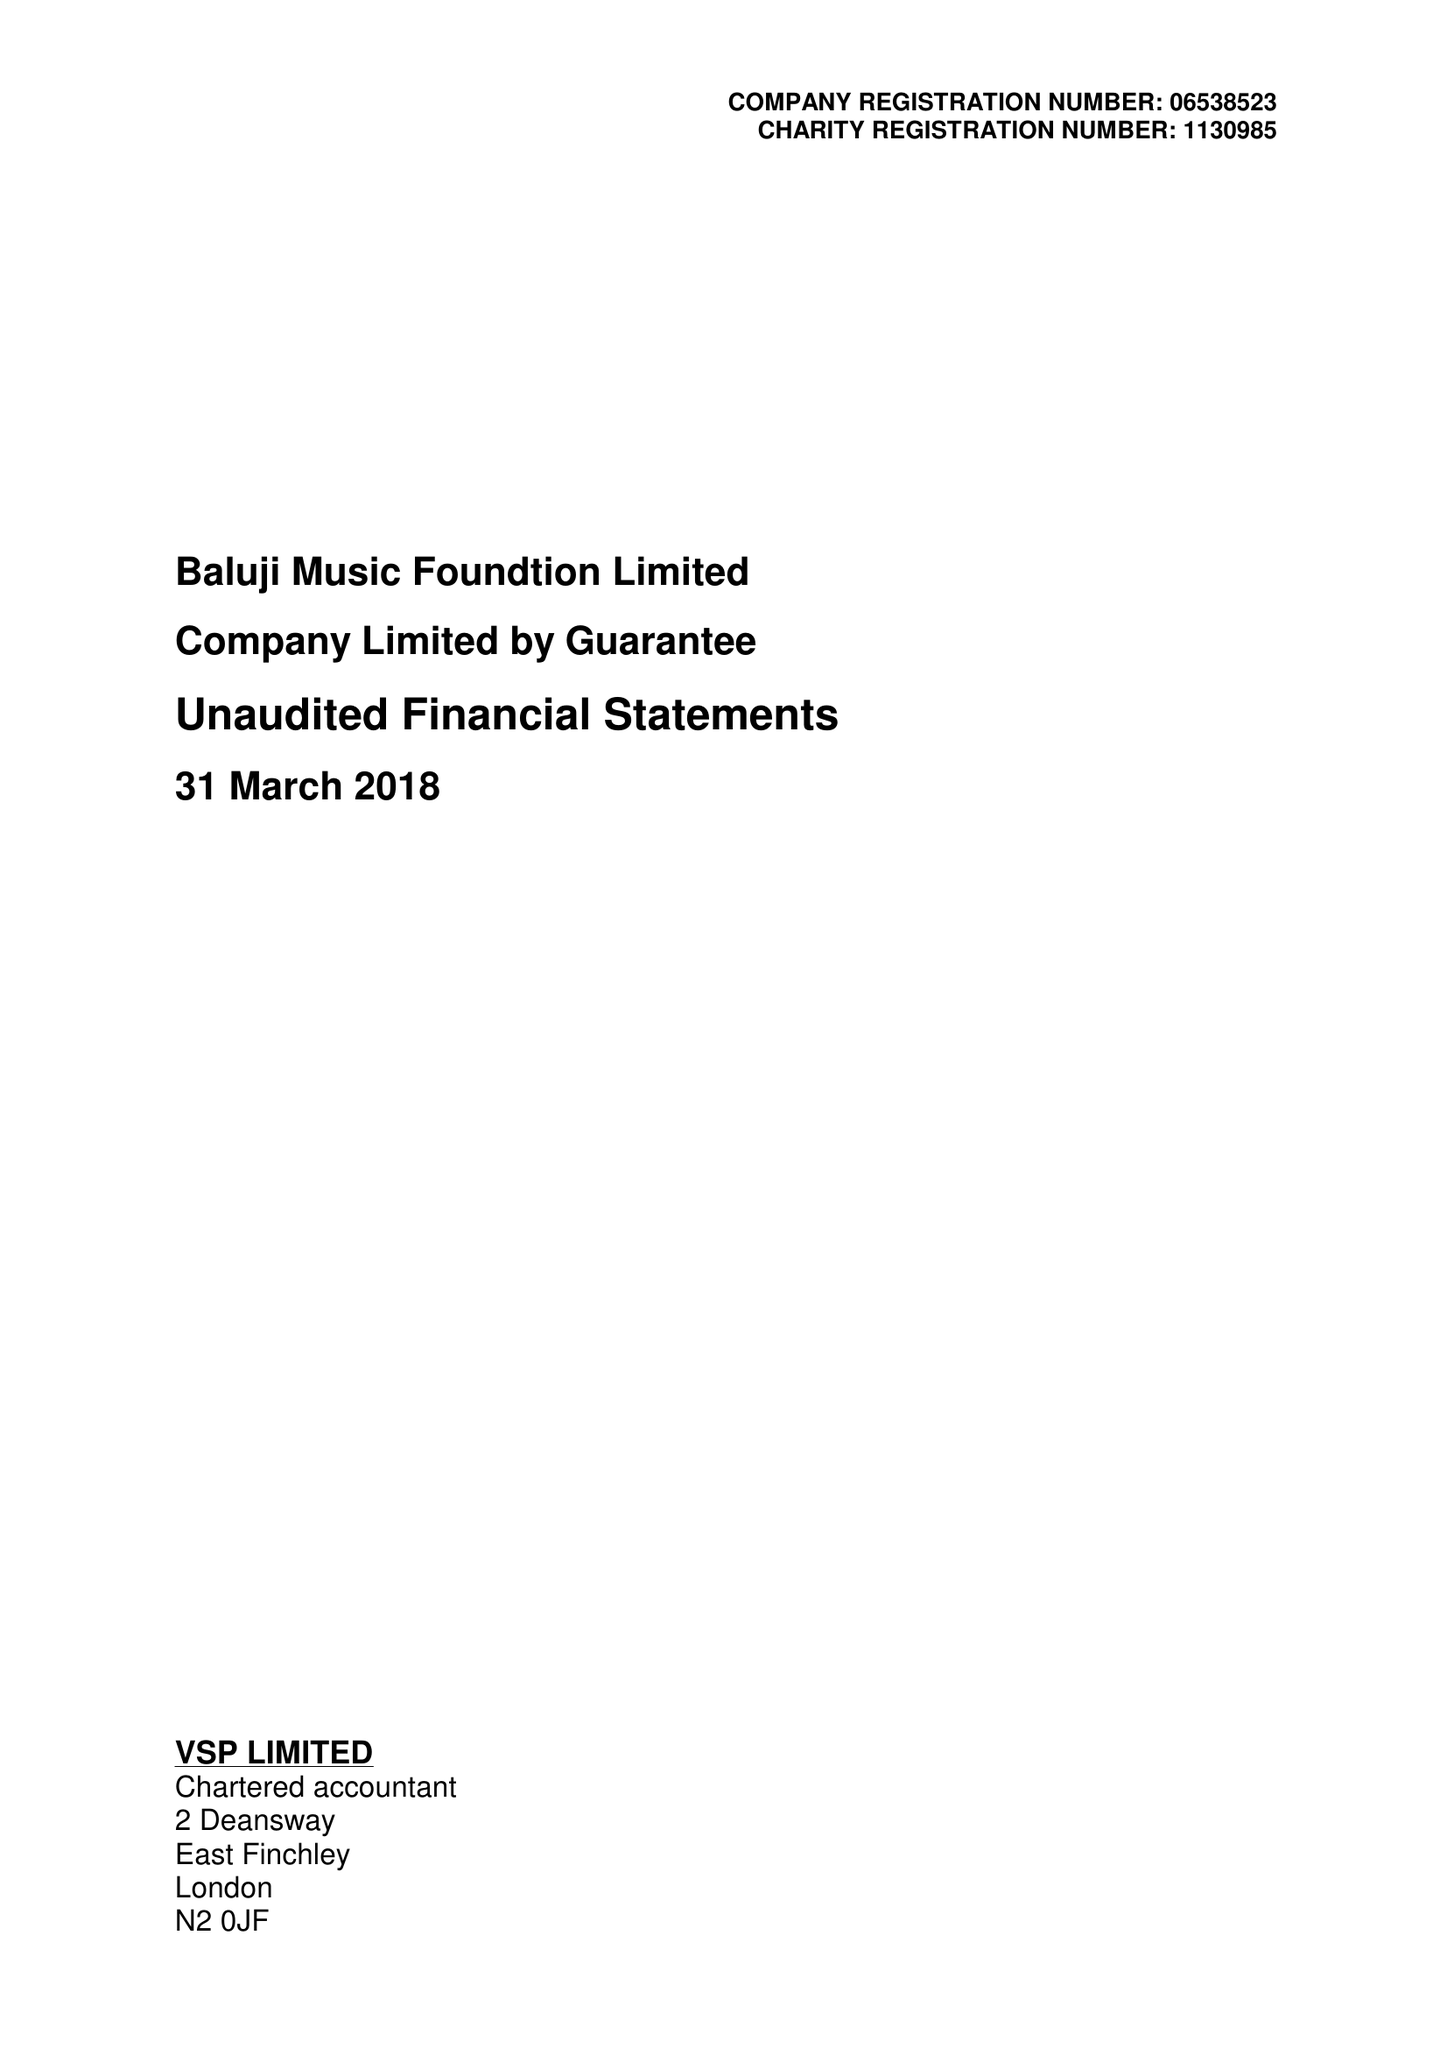What is the value for the report_date?
Answer the question using a single word or phrase. 2018-03-31 